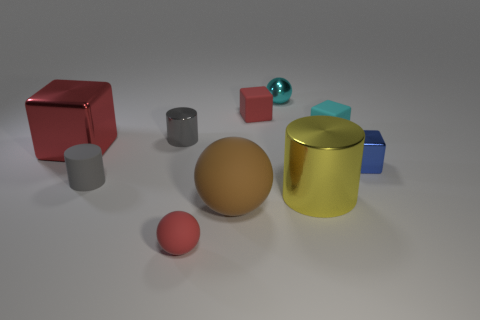What might be the purpose of this collection of objects? Given the variety and the arrangement, it looks like a visual composition intended to showcase different shapes, colors, and materials. The purpose could be an artistic display or a test render to demonstrate rendering techniques in computer graphics, including how light interacts with various surfaces. 